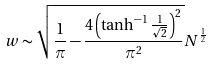Convert formula to latex. <formula><loc_0><loc_0><loc_500><loc_500>w \sim \sqrt { \frac { 1 } { \pi } - \frac { 4 \left ( \tanh ^ { - 1 } \frac { 1 } { \sqrt { 2 } } \right ) ^ { 2 } } { \pi ^ { 2 } } } N ^ { \frac { 1 } { 2 } }</formula> 